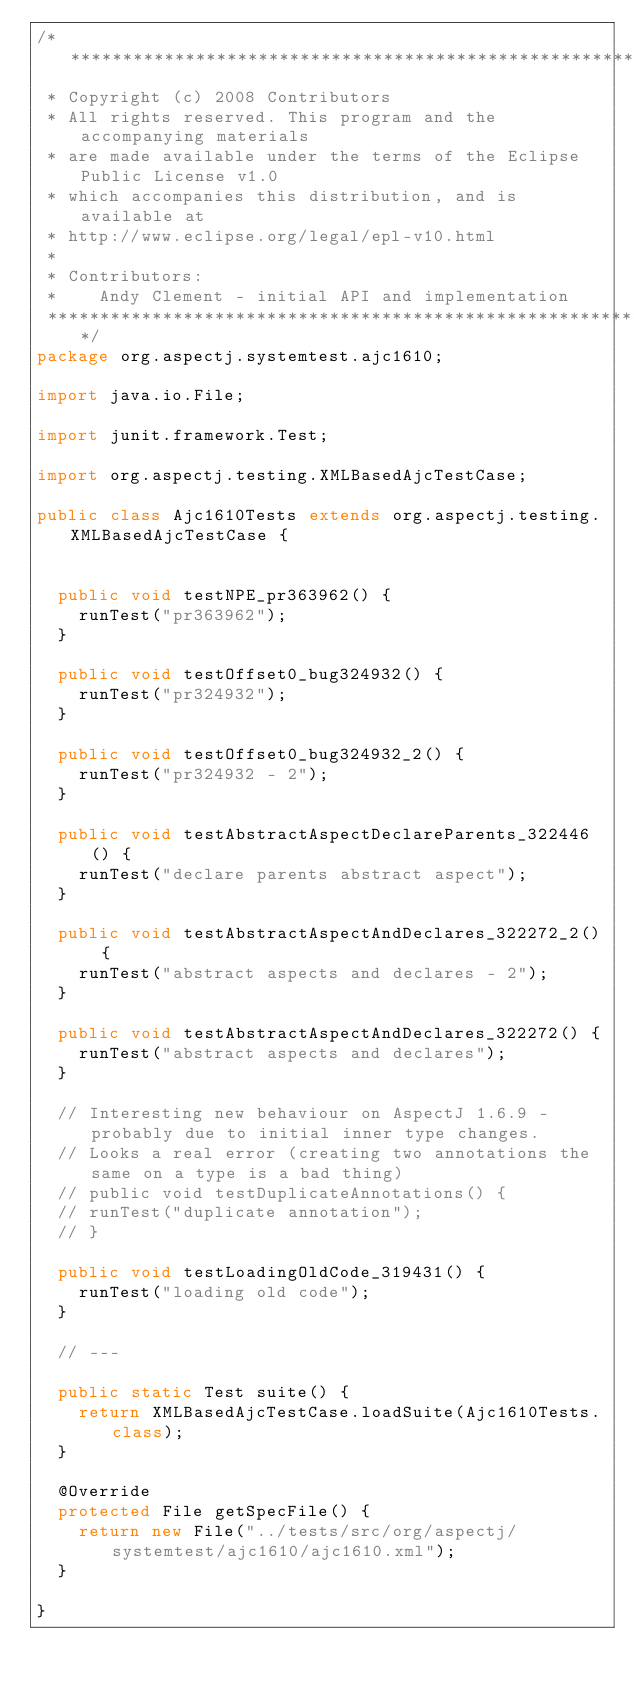Convert code to text. <code><loc_0><loc_0><loc_500><loc_500><_Java_>/*******************************************************************************
 * Copyright (c) 2008 Contributors
 * All rights reserved. This program and the accompanying materials
 * are made available under the terms of the Eclipse Public License v1.0
 * which accompanies this distribution, and is available at
 * http://www.eclipse.org/legal/epl-v10.html
 *
 * Contributors:
 *    Andy Clement - initial API and implementation
 *******************************************************************************/
package org.aspectj.systemtest.ajc1610;

import java.io.File;

import junit.framework.Test;

import org.aspectj.testing.XMLBasedAjcTestCase;

public class Ajc1610Tests extends org.aspectj.testing.XMLBasedAjcTestCase {

	
	public void testNPE_pr363962() {
		runTest("pr363962");
	}
	
	public void testOffset0_bug324932() {
		runTest("pr324932");
	}

	public void testOffset0_bug324932_2() {
		runTest("pr324932 - 2");
	}

	public void testAbstractAspectDeclareParents_322446() {
		runTest("declare parents abstract aspect");
	}

	public void testAbstractAspectAndDeclares_322272_2() {
		runTest("abstract aspects and declares - 2");
	}

	public void testAbstractAspectAndDeclares_322272() {
		runTest("abstract aspects and declares");
	}

	// Interesting new behaviour on AspectJ 1.6.9 - probably due to initial inner type changes.
	// Looks a real error (creating two annotations the same on a type is a bad thing)
	// public void testDuplicateAnnotations() {
	// runTest("duplicate annotation");
	// }

	public void testLoadingOldCode_319431() {
		runTest("loading old code");
	}

	// ---

	public static Test suite() {
		return XMLBasedAjcTestCase.loadSuite(Ajc1610Tests.class);
	}

	@Override
	protected File getSpecFile() {
		return new File("../tests/src/org/aspectj/systemtest/ajc1610/ajc1610.xml");
	}

}</code> 